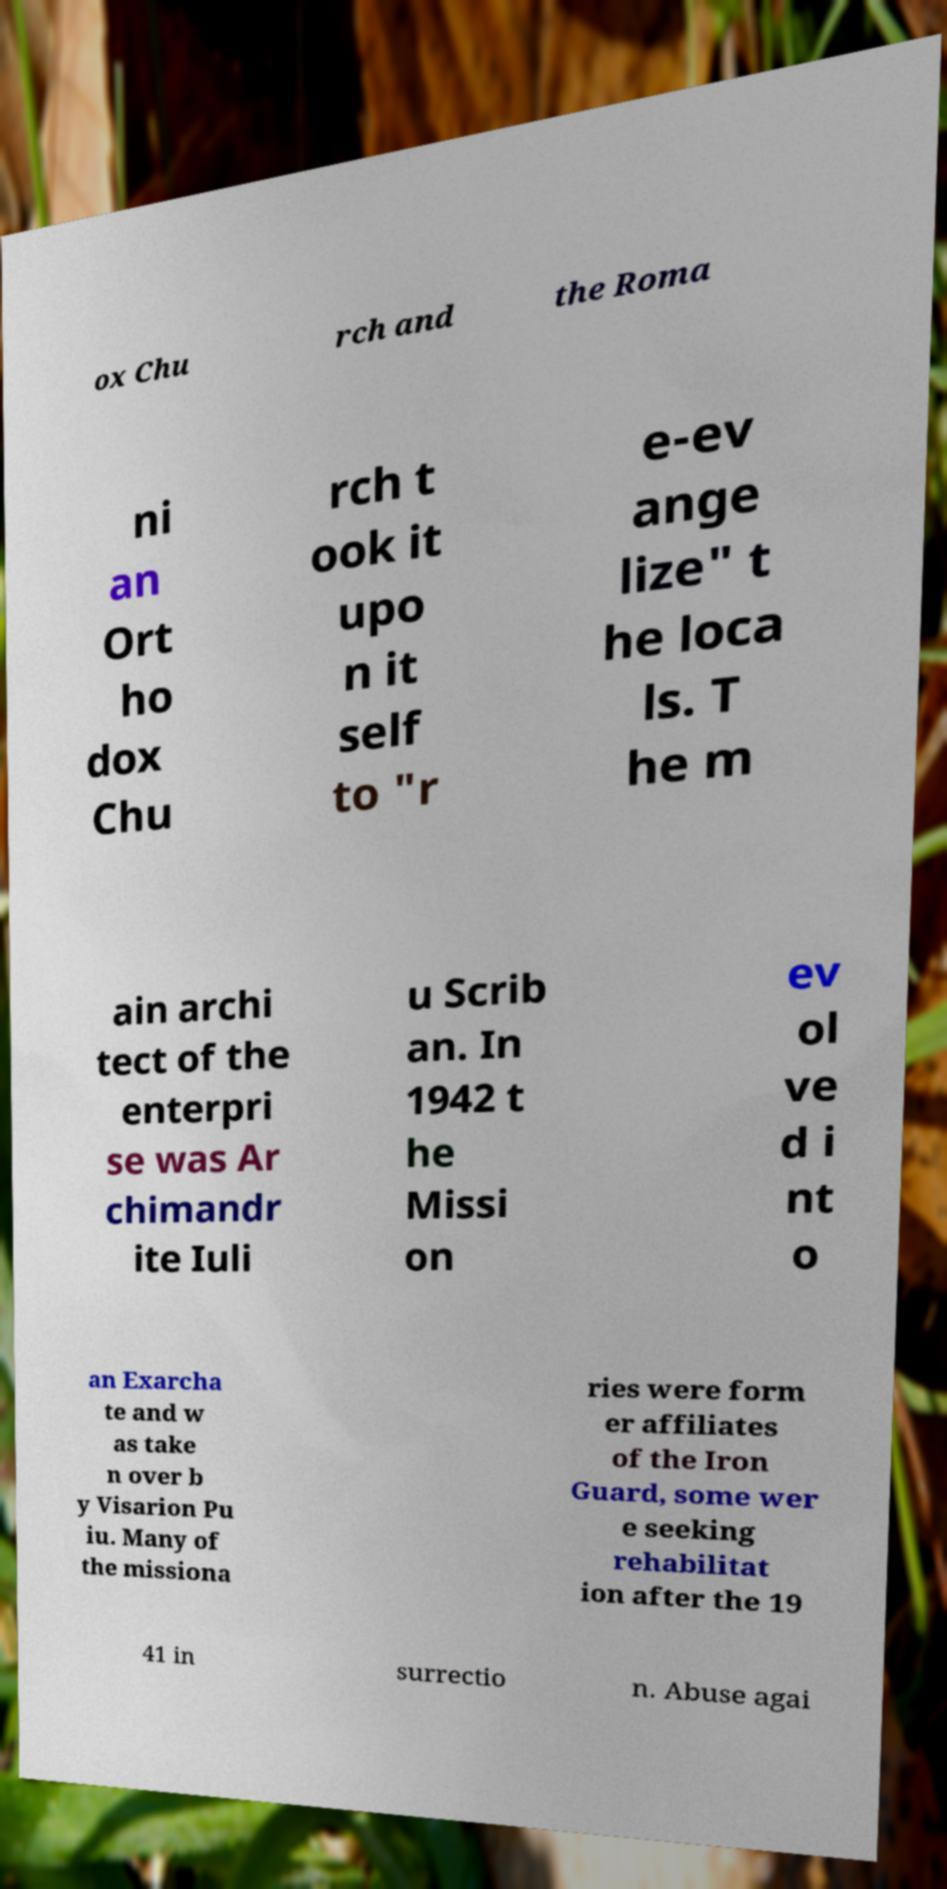What messages or text are displayed in this image? I need them in a readable, typed format. ox Chu rch and the Roma ni an Ort ho dox Chu rch t ook it upo n it self to "r e-ev ange lize" t he loca ls. T he m ain archi tect of the enterpri se was Ar chimandr ite Iuli u Scrib an. In 1942 t he Missi on ev ol ve d i nt o an Exarcha te and w as take n over b y Visarion Pu iu. Many of the missiona ries were form er affiliates of the Iron Guard, some wer e seeking rehabilitat ion after the 19 41 in surrectio n. Abuse agai 